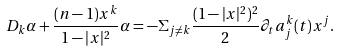<formula> <loc_0><loc_0><loc_500><loc_500>D _ { k } \alpha + \frac { ( n - 1 ) x ^ { k } } { 1 - | x | ^ { 2 } } \alpha = - \Sigma _ { j \not = k } \frac { ( 1 - | x | ^ { 2 } ) ^ { 2 } } { 2 } \partial _ { t } a ^ { k } _ { j } ( t ) x ^ { j } .</formula> 